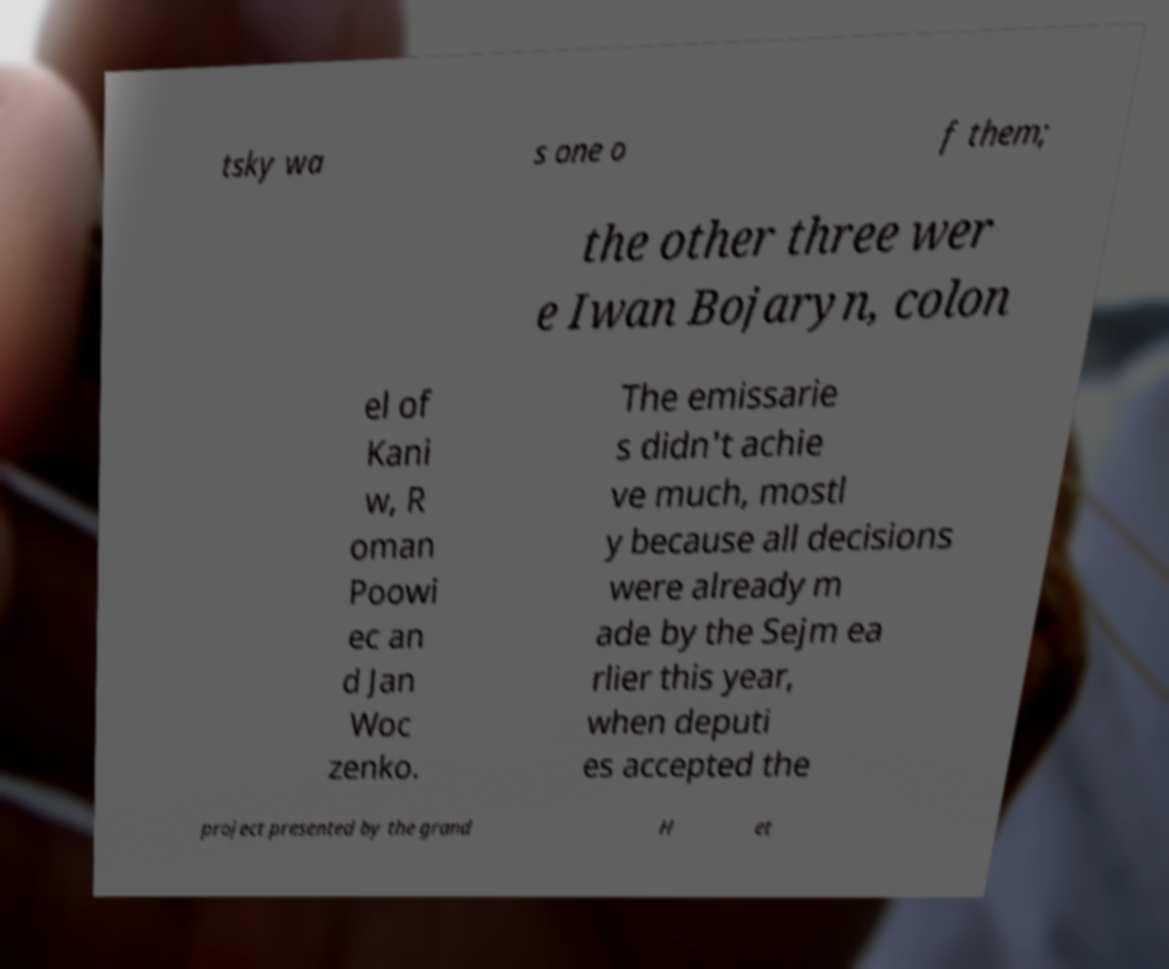What messages or text are displayed in this image? I need them in a readable, typed format. tsky wa s one o f them; the other three wer e Iwan Bojaryn, colon el of Kani w, R oman Poowi ec an d Jan Woc zenko. The emissarie s didn't achie ve much, mostl y because all decisions were already m ade by the Sejm ea rlier this year, when deputi es accepted the project presented by the grand H et 